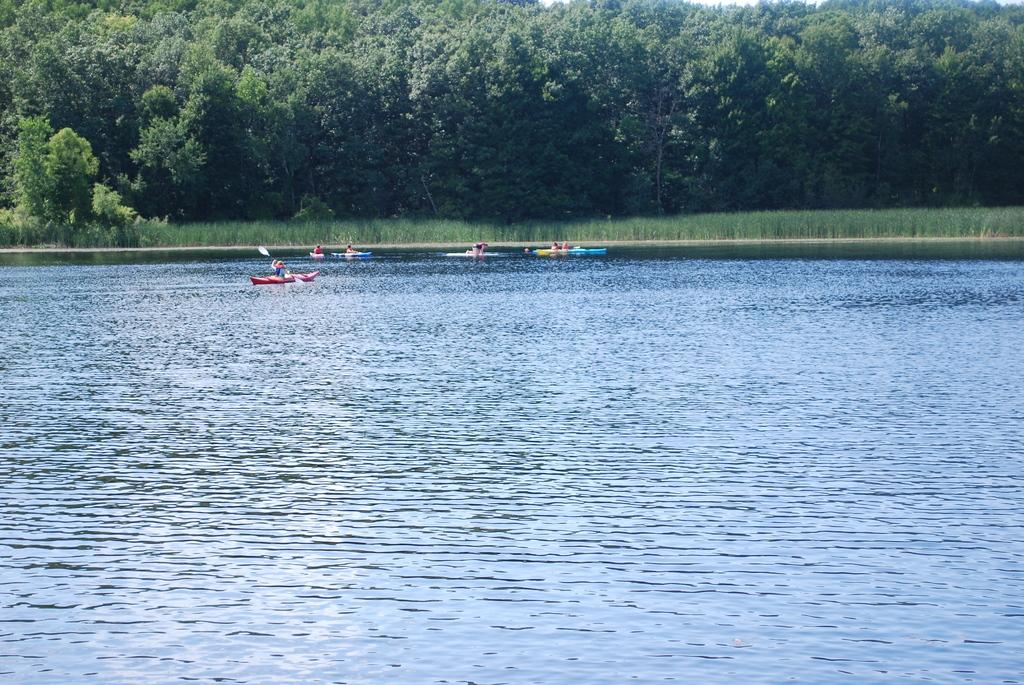What type of body of water is present in the image? There is a lake in the image. What can be seen in the surroundings of the lake? There are many trees and plants in the image. What activity are people engaged in on the lake? There are people rowing boats in the image. What innovative idea can be seen in the image? There is no specific idea depicted in the image; it shows a lake, trees, plants, and people rowing boats. 